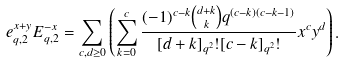<formula> <loc_0><loc_0><loc_500><loc_500>e _ { q , 2 } ^ { x + y } E _ { q , 2 } ^ { - x } = \sum _ { c , d \geq 0 } \left ( \sum _ { k = 0 } ^ { c } \frac { ( - 1 ) ^ { c - k } { { d + k } \choose k } q ^ { ( c - k ) ( c - k - 1 ) } } { [ d + k ] _ { q ^ { 2 } } ! [ c - k ] _ { q ^ { 2 } } ! } x ^ { c } y ^ { d } \right ) .</formula> 